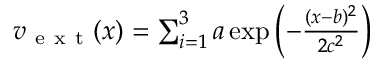<formula> <loc_0><loc_0><loc_500><loc_500>\begin{array} { r } { v _ { e x t } ( x ) = \sum _ { i = 1 } ^ { 3 } a \exp \left ( - \frac { ( x - b ) ^ { 2 } } { 2 c ^ { 2 } } \right ) } \end{array}</formula> 